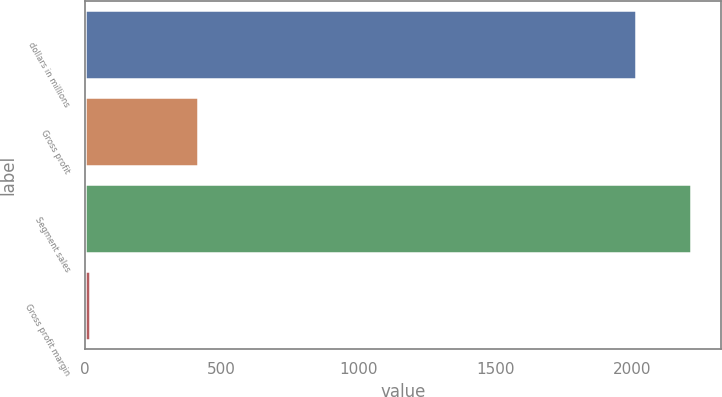Convert chart to OTSL. <chart><loc_0><loc_0><loc_500><loc_500><bar_chart><fcel>dollars in millions<fcel>Gross profit<fcel>Segment sales<fcel>Gross profit margin<nl><fcel>2013<fcel>413.3<fcel>2213.46<fcel>20.4<nl></chart> 